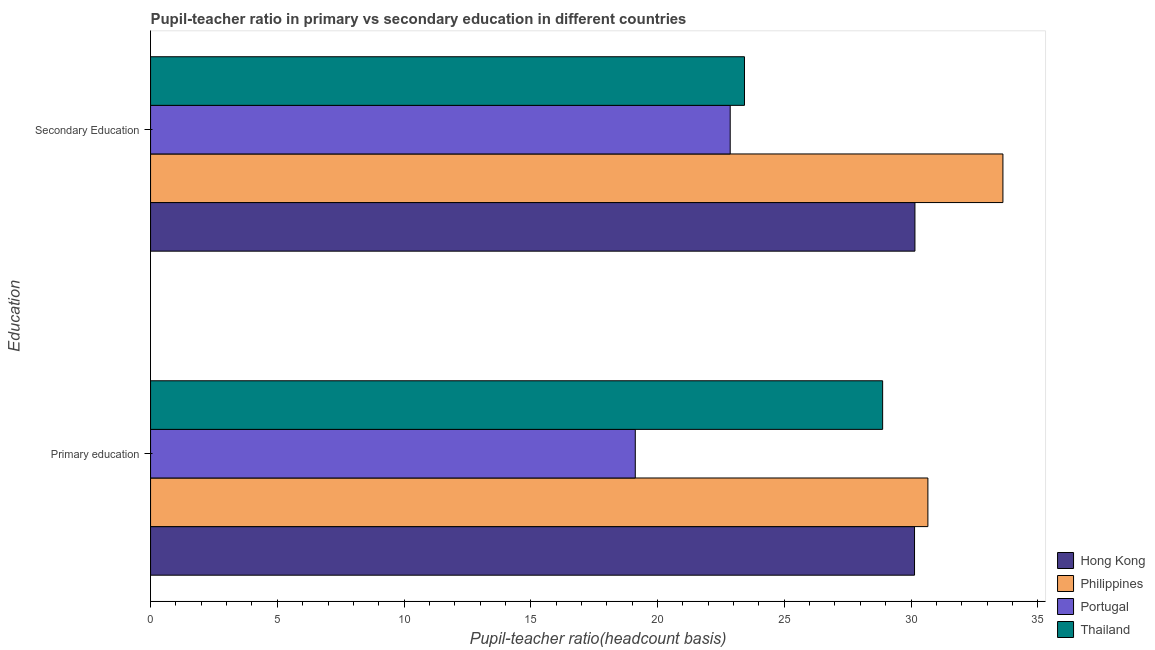How many different coloured bars are there?
Provide a succinct answer. 4. How many groups of bars are there?
Your response must be concise. 2. Are the number of bars per tick equal to the number of legend labels?
Your answer should be compact. Yes. Are the number of bars on each tick of the Y-axis equal?
Provide a short and direct response. Yes. How many bars are there on the 1st tick from the top?
Keep it short and to the point. 4. How many bars are there on the 1st tick from the bottom?
Provide a short and direct response. 4. What is the label of the 2nd group of bars from the top?
Your response must be concise. Primary education. What is the pupil-teacher ratio in primary education in Portugal?
Your answer should be very brief. 19.12. Across all countries, what is the maximum pupil teacher ratio on secondary education?
Keep it short and to the point. 33.63. Across all countries, what is the minimum pupil teacher ratio on secondary education?
Your answer should be compact. 22.87. What is the total pupil-teacher ratio in primary education in the graph?
Your response must be concise. 108.81. What is the difference between the pupil-teacher ratio in primary education in Philippines and that in Hong Kong?
Keep it short and to the point. 0.53. What is the difference between the pupil teacher ratio on secondary education in Portugal and the pupil-teacher ratio in primary education in Hong Kong?
Your response must be concise. -7.27. What is the average pupil-teacher ratio in primary education per country?
Your answer should be very brief. 27.2. What is the difference between the pupil teacher ratio on secondary education and pupil-teacher ratio in primary education in Thailand?
Ensure brevity in your answer.  -5.45. What is the ratio of the pupil teacher ratio on secondary education in Thailand to that in Portugal?
Provide a succinct answer. 1.02. What does the 1st bar from the top in Primary education represents?
Provide a short and direct response. Thailand. What does the 4th bar from the bottom in Primary education represents?
Make the answer very short. Thailand. How many bars are there?
Offer a terse response. 8. Are all the bars in the graph horizontal?
Your response must be concise. Yes. Are the values on the major ticks of X-axis written in scientific E-notation?
Make the answer very short. No. Where does the legend appear in the graph?
Your answer should be compact. Bottom right. How many legend labels are there?
Provide a succinct answer. 4. How are the legend labels stacked?
Your response must be concise. Vertical. What is the title of the graph?
Provide a succinct answer. Pupil-teacher ratio in primary vs secondary education in different countries. Does "Comoros" appear as one of the legend labels in the graph?
Offer a very short reply. No. What is the label or title of the X-axis?
Ensure brevity in your answer.  Pupil-teacher ratio(headcount basis). What is the label or title of the Y-axis?
Your response must be concise. Education. What is the Pupil-teacher ratio(headcount basis) in Hong Kong in Primary education?
Your answer should be compact. 30.14. What is the Pupil-teacher ratio(headcount basis) of Philippines in Primary education?
Your response must be concise. 30.67. What is the Pupil-teacher ratio(headcount basis) in Portugal in Primary education?
Offer a very short reply. 19.12. What is the Pupil-teacher ratio(headcount basis) of Thailand in Primary education?
Provide a succinct answer. 28.88. What is the Pupil-teacher ratio(headcount basis) in Hong Kong in Secondary Education?
Provide a succinct answer. 30.15. What is the Pupil-teacher ratio(headcount basis) in Philippines in Secondary Education?
Make the answer very short. 33.63. What is the Pupil-teacher ratio(headcount basis) in Portugal in Secondary Education?
Offer a very short reply. 22.87. What is the Pupil-teacher ratio(headcount basis) of Thailand in Secondary Education?
Your response must be concise. 23.43. Across all Education, what is the maximum Pupil-teacher ratio(headcount basis) in Hong Kong?
Offer a terse response. 30.15. Across all Education, what is the maximum Pupil-teacher ratio(headcount basis) of Philippines?
Your response must be concise. 33.63. Across all Education, what is the maximum Pupil-teacher ratio(headcount basis) of Portugal?
Provide a short and direct response. 22.87. Across all Education, what is the maximum Pupil-teacher ratio(headcount basis) of Thailand?
Keep it short and to the point. 28.88. Across all Education, what is the minimum Pupil-teacher ratio(headcount basis) of Hong Kong?
Make the answer very short. 30.14. Across all Education, what is the minimum Pupil-teacher ratio(headcount basis) in Philippines?
Your answer should be very brief. 30.67. Across all Education, what is the minimum Pupil-teacher ratio(headcount basis) of Portugal?
Ensure brevity in your answer.  19.12. Across all Education, what is the minimum Pupil-teacher ratio(headcount basis) in Thailand?
Provide a short and direct response. 23.43. What is the total Pupil-teacher ratio(headcount basis) of Hong Kong in the graph?
Give a very brief answer. 60.29. What is the total Pupil-teacher ratio(headcount basis) of Philippines in the graph?
Your answer should be very brief. 64.29. What is the total Pupil-teacher ratio(headcount basis) in Portugal in the graph?
Provide a succinct answer. 41.99. What is the total Pupil-teacher ratio(headcount basis) of Thailand in the graph?
Give a very brief answer. 52.31. What is the difference between the Pupil-teacher ratio(headcount basis) in Hong Kong in Primary education and that in Secondary Education?
Provide a succinct answer. -0.02. What is the difference between the Pupil-teacher ratio(headcount basis) of Philippines in Primary education and that in Secondary Education?
Make the answer very short. -2.96. What is the difference between the Pupil-teacher ratio(headcount basis) of Portugal in Primary education and that in Secondary Education?
Your answer should be compact. -3.74. What is the difference between the Pupil-teacher ratio(headcount basis) of Thailand in Primary education and that in Secondary Education?
Your answer should be very brief. 5.45. What is the difference between the Pupil-teacher ratio(headcount basis) in Hong Kong in Primary education and the Pupil-teacher ratio(headcount basis) in Philippines in Secondary Education?
Ensure brevity in your answer.  -3.49. What is the difference between the Pupil-teacher ratio(headcount basis) in Hong Kong in Primary education and the Pupil-teacher ratio(headcount basis) in Portugal in Secondary Education?
Offer a very short reply. 7.27. What is the difference between the Pupil-teacher ratio(headcount basis) of Hong Kong in Primary education and the Pupil-teacher ratio(headcount basis) of Thailand in Secondary Education?
Provide a succinct answer. 6.71. What is the difference between the Pupil-teacher ratio(headcount basis) in Philippines in Primary education and the Pupil-teacher ratio(headcount basis) in Portugal in Secondary Education?
Make the answer very short. 7.8. What is the difference between the Pupil-teacher ratio(headcount basis) of Philippines in Primary education and the Pupil-teacher ratio(headcount basis) of Thailand in Secondary Education?
Provide a short and direct response. 7.24. What is the difference between the Pupil-teacher ratio(headcount basis) in Portugal in Primary education and the Pupil-teacher ratio(headcount basis) in Thailand in Secondary Education?
Your answer should be very brief. -4.31. What is the average Pupil-teacher ratio(headcount basis) of Hong Kong per Education?
Offer a very short reply. 30.15. What is the average Pupil-teacher ratio(headcount basis) in Philippines per Education?
Make the answer very short. 32.15. What is the average Pupil-teacher ratio(headcount basis) in Portugal per Education?
Your answer should be very brief. 20.99. What is the average Pupil-teacher ratio(headcount basis) in Thailand per Education?
Offer a very short reply. 26.16. What is the difference between the Pupil-teacher ratio(headcount basis) in Hong Kong and Pupil-teacher ratio(headcount basis) in Philippines in Primary education?
Your response must be concise. -0.53. What is the difference between the Pupil-teacher ratio(headcount basis) in Hong Kong and Pupil-teacher ratio(headcount basis) in Portugal in Primary education?
Your answer should be very brief. 11.02. What is the difference between the Pupil-teacher ratio(headcount basis) of Hong Kong and Pupil-teacher ratio(headcount basis) of Thailand in Primary education?
Offer a very short reply. 1.26. What is the difference between the Pupil-teacher ratio(headcount basis) in Philippines and Pupil-teacher ratio(headcount basis) in Portugal in Primary education?
Your answer should be compact. 11.54. What is the difference between the Pupil-teacher ratio(headcount basis) of Philippines and Pupil-teacher ratio(headcount basis) of Thailand in Primary education?
Ensure brevity in your answer.  1.78. What is the difference between the Pupil-teacher ratio(headcount basis) of Portugal and Pupil-teacher ratio(headcount basis) of Thailand in Primary education?
Offer a very short reply. -9.76. What is the difference between the Pupil-teacher ratio(headcount basis) in Hong Kong and Pupil-teacher ratio(headcount basis) in Philippines in Secondary Education?
Your answer should be very brief. -3.47. What is the difference between the Pupil-teacher ratio(headcount basis) in Hong Kong and Pupil-teacher ratio(headcount basis) in Portugal in Secondary Education?
Give a very brief answer. 7.29. What is the difference between the Pupil-teacher ratio(headcount basis) of Hong Kong and Pupil-teacher ratio(headcount basis) of Thailand in Secondary Education?
Your answer should be compact. 6.72. What is the difference between the Pupil-teacher ratio(headcount basis) in Philippines and Pupil-teacher ratio(headcount basis) in Portugal in Secondary Education?
Provide a short and direct response. 10.76. What is the difference between the Pupil-teacher ratio(headcount basis) in Philippines and Pupil-teacher ratio(headcount basis) in Thailand in Secondary Education?
Make the answer very short. 10.2. What is the difference between the Pupil-teacher ratio(headcount basis) of Portugal and Pupil-teacher ratio(headcount basis) of Thailand in Secondary Education?
Offer a very short reply. -0.56. What is the ratio of the Pupil-teacher ratio(headcount basis) in Hong Kong in Primary education to that in Secondary Education?
Your answer should be compact. 1. What is the ratio of the Pupil-teacher ratio(headcount basis) of Philippines in Primary education to that in Secondary Education?
Your answer should be compact. 0.91. What is the ratio of the Pupil-teacher ratio(headcount basis) in Portugal in Primary education to that in Secondary Education?
Keep it short and to the point. 0.84. What is the ratio of the Pupil-teacher ratio(headcount basis) in Thailand in Primary education to that in Secondary Education?
Make the answer very short. 1.23. What is the difference between the highest and the second highest Pupil-teacher ratio(headcount basis) of Hong Kong?
Make the answer very short. 0.02. What is the difference between the highest and the second highest Pupil-teacher ratio(headcount basis) of Philippines?
Offer a terse response. 2.96. What is the difference between the highest and the second highest Pupil-teacher ratio(headcount basis) of Portugal?
Make the answer very short. 3.74. What is the difference between the highest and the second highest Pupil-teacher ratio(headcount basis) of Thailand?
Ensure brevity in your answer.  5.45. What is the difference between the highest and the lowest Pupil-teacher ratio(headcount basis) in Hong Kong?
Offer a very short reply. 0.02. What is the difference between the highest and the lowest Pupil-teacher ratio(headcount basis) in Philippines?
Offer a terse response. 2.96. What is the difference between the highest and the lowest Pupil-teacher ratio(headcount basis) in Portugal?
Give a very brief answer. 3.74. What is the difference between the highest and the lowest Pupil-teacher ratio(headcount basis) in Thailand?
Provide a short and direct response. 5.45. 